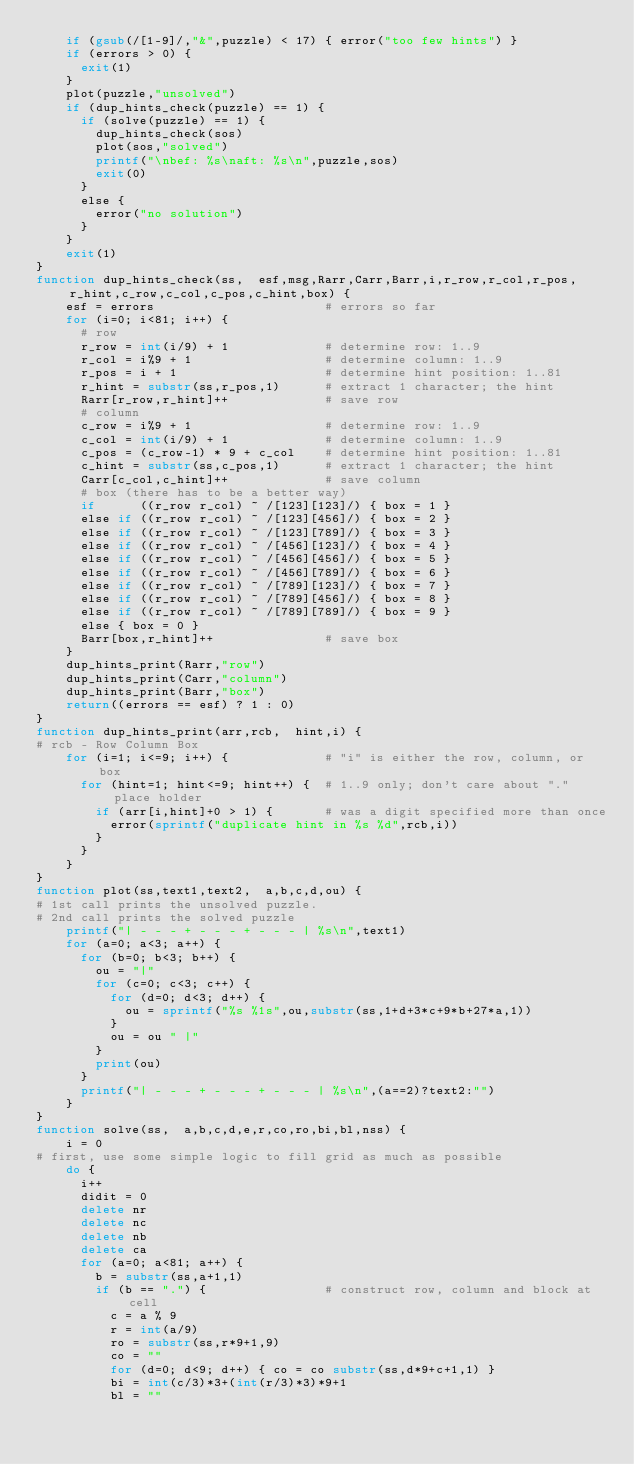Convert code to text. <code><loc_0><loc_0><loc_500><loc_500><_Awk_>    if (gsub(/[1-9]/,"&",puzzle) < 17) { error("too few hints") }
    if (errors > 0) {
      exit(1)
    }
    plot(puzzle,"unsolved")
    if (dup_hints_check(puzzle) == 1) {
      if (solve(puzzle) == 1) {
        dup_hints_check(sos)
        plot(sos,"solved")
        printf("\nbef: %s\naft: %s\n",puzzle,sos)
        exit(0)
      }
      else {
        error("no solution")
      }
    }
    exit(1)
}
function dup_hints_check(ss,  esf,msg,Rarr,Carr,Barr,i,r_row,r_col,r_pos,r_hint,c_row,c_col,c_pos,c_hint,box) {
    esf = errors                       # errors so far
    for (i=0; i<81; i++) {
      # row
      r_row = int(i/9) + 1             # determine row: 1..9
      r_col = i%9 + 1                  # determine column: 1..9
      r_pos = i + 1                    # determine hint position: 1..81
      r_hint = substr(ss,r_pos,1)      # extract 1 character; the hint
      Rarr[r_row,r_hint]++             # save row
      # column
      c_row = i%9 + 1                  # determine row: 1..9
      c_col = int(i/9) + 1             # determine column: 1..9
      c_pos = (c_row-1) * 9 + c_col    # determine hint position: 1..81
      c_hint = substr(ss,c_pos,1)      # extract 1 character; the hint
      Carr[c_col,c_hint]++             # save column
      # box (there has to be a better way)
      if      ((r_row r_col) ~ /[123][123]/) { box = 1 }
      else if ((r_row r_col) ~ /[123][456]/) { box = 2 }
      else if ((r_row r_col) ~ /[123][789]/) { box = 3 }
      else if ((r_row r_col) ~ /[456][123]/) { box = 4 }
      else if ((r_row r_col) ~ /[456][456]/) { box = 5 }
      else if ((r_row r_col) ~ /[456][789]/) { box = 6 }
      else if ((r_row r_col) ~ /[789][123]/) { box = 7 }
      else if ((r_row r_col) ~ /[789][456]/) { box = 8 }
      else if ((r_row r_col) ~ /[789][789]/) { box = 9 }
      else { box = 0 }
      Barr[box,r_hint]++               # save box
    }
    dup_hints_print(Rarr,"row")
    dup_hints_print(Carr,"column")
    dup_hints_print(Barr,"box")
    return((errors == esf) ? 1 : 0)
}
function dup_hints_print(arr,rcb,  hint,i) {
# rcb - Row Column Box
    for (i=1; i<=9; i++) {             # "i" is either the row, column, or box
      for (hint=1; hint<=9; hint++) {  # 1..9 only; don't care about "." place holder
        if (arr[i,hint]+0 > 1) {       # was a digit specified more than once
          error(sprintf("duplicate hint in %s %d",rcb,i))
        }
      }
    }
}
function plot(ss,text1,text2,  a,b,c,d,ou) {
# 1st call prints the unsolved puzzle.
# 2nd call prints the solved puzzle
    printf("| - - - + - - - + - - - | %s\n",text1)
    for (a=0; a<3; a++) {
      for (b=0; b<3; b++) {
        ou = "|"
        for (c=0; c<3; c++) {
          for (d=0; d<3; d++) {
            ou = sprintf("%s %1s",ou,substr(ss,1+d+3*c+9*b+27*a,1))
          }
          ou = ou " |"
        }
        print(ou)
      }
      printf("| - - - + - - - + - - - | %s\n",(a==2)?text2:"")
    }
}
function solve(ss,  a,b,c,d,e,r,co,ro,bi,bl,nss) {
    i = 0
# first, use some simple logic to fill grid as much as possible
    do {
      i++
      didit = 0
      delete nr
      delete nc
      delete nb
      delete ca
      for (a=0; a<81; a++) {
        b = substr(ss,a+1,1)
        if (b == ".") {                # construct row, column and block at cell
          c = a % 9
          r = int(a/9)
          ro = substr(ss,r*9+1,9)
          co = ""
          for (d=0; d<9; d++) { co = co substr(ss,d*9+c+1,1) }
          bi = int(c/3)*3+(int(r/3)*3)*9+1
          bl = ""</code> 